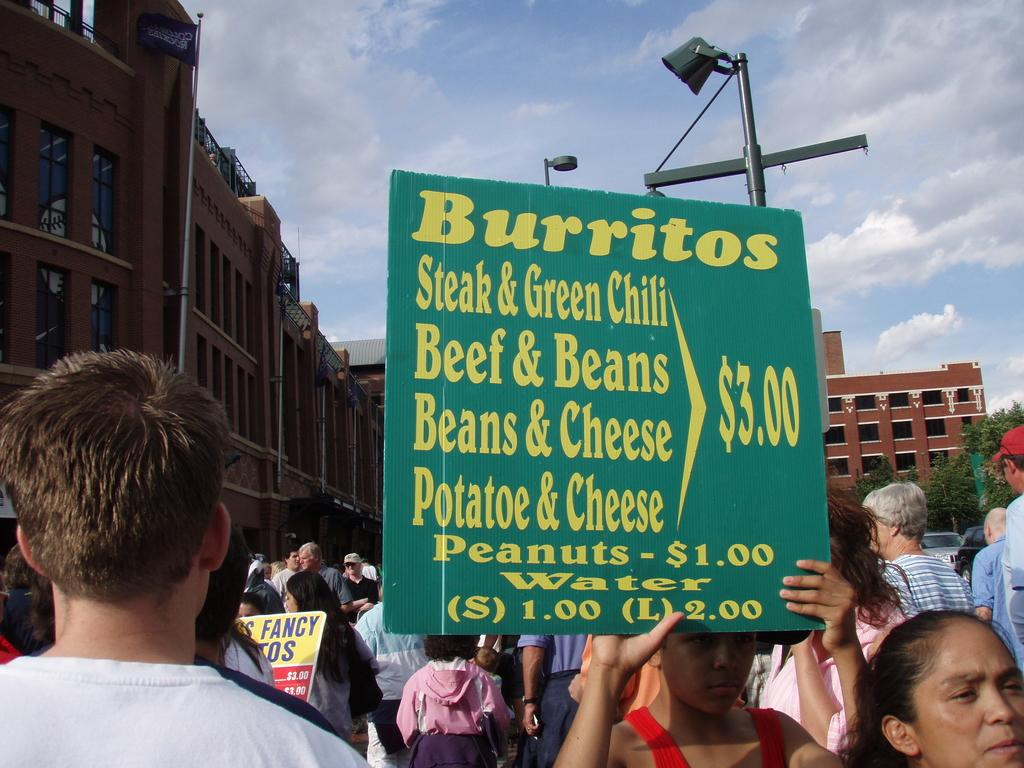What are the people in the image doing? The people in the image are standing on the road. What are some of the people holding? Some people are holding posters. What can be read on the posters? There is text on the posters. What can be seen in the background of the image? There are buildings, poles, trees, and the sky visible in the background. What hobbies do the secretaries have in the image? There are no secretaries present in the image, so it is not possible to determine their hobbies. 